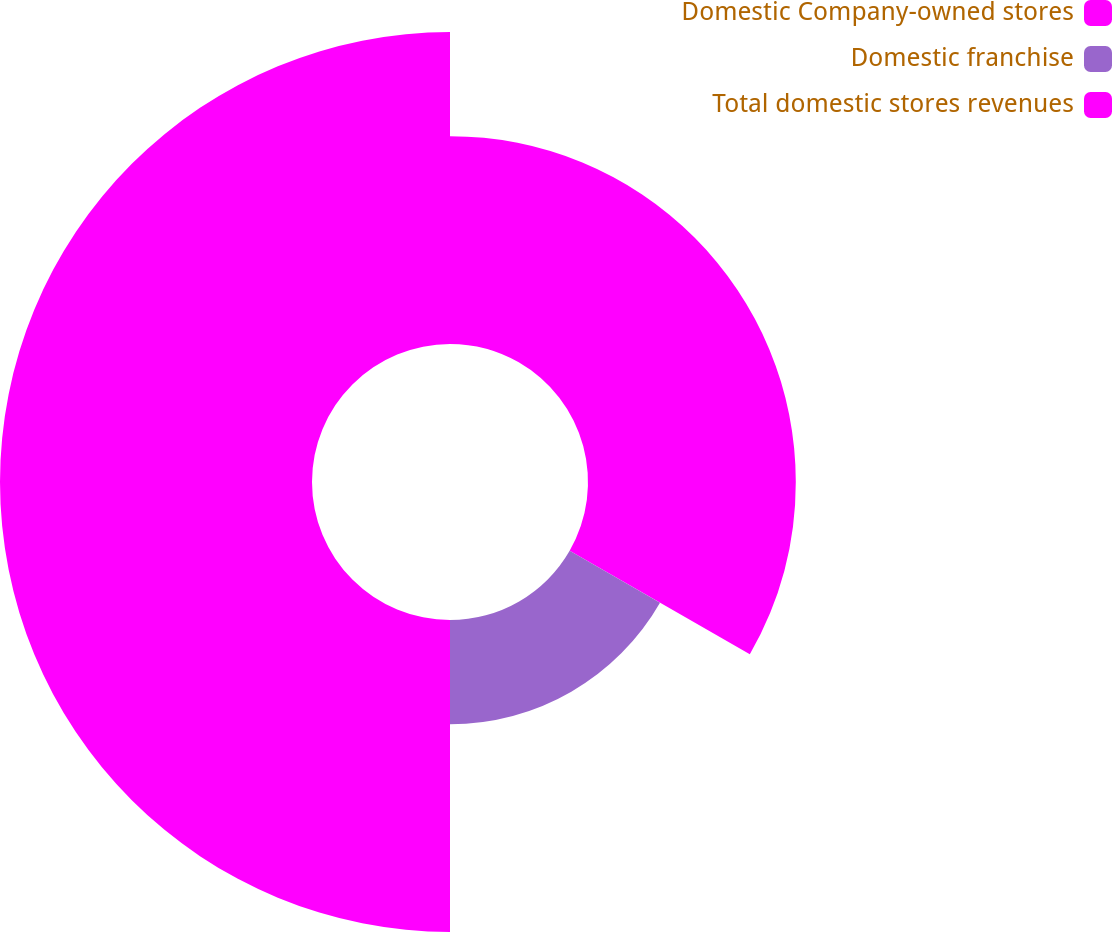Convert chart to OTSL. <chart><loc_0><loc_0><loc_500><loc_500><pie_chart><fcel>Domestic Company-owned stores<fcel>Domestic franchise<fcel>Total domestic stores revenues<nl><fcel>33.3%<fcel>16.7%<fcel>50.0%<nl></chart> 